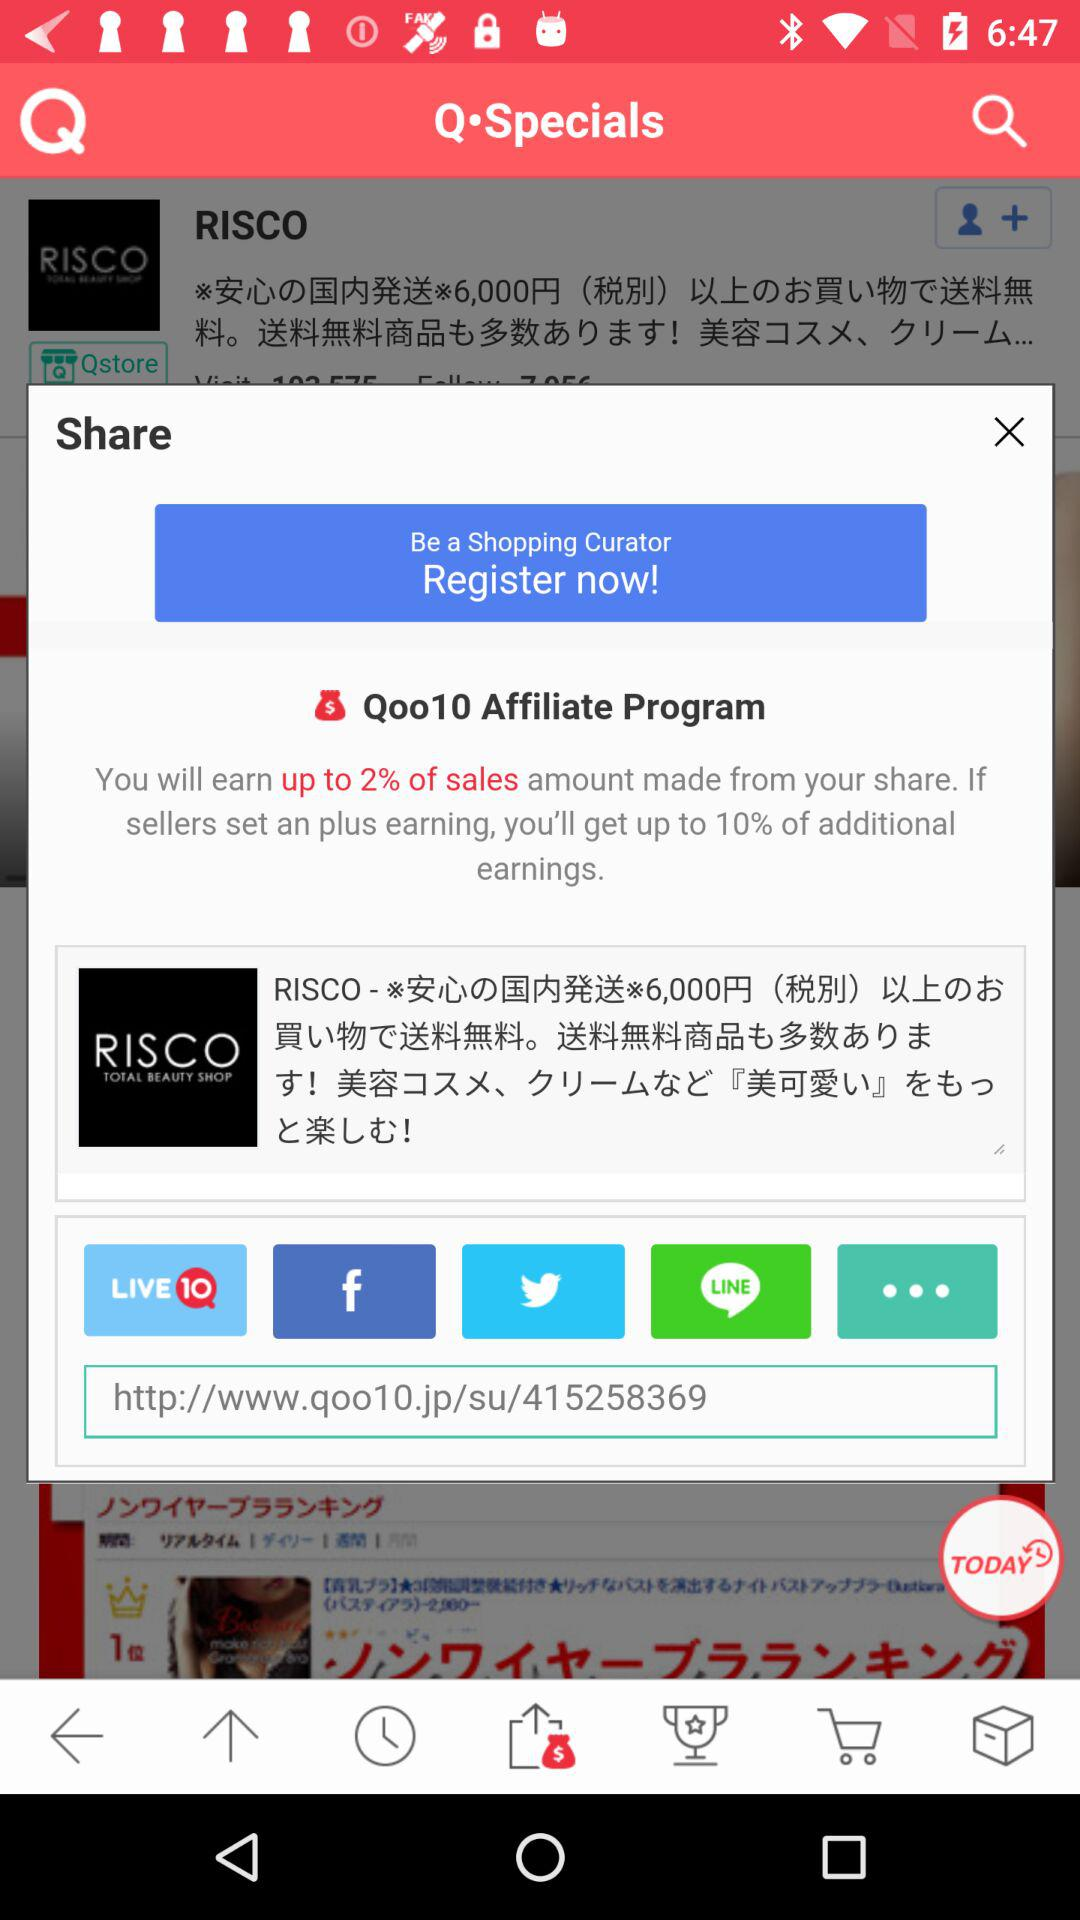What percentage of additional earnings can the user get? The user can get up to 10% of additional earnings. 